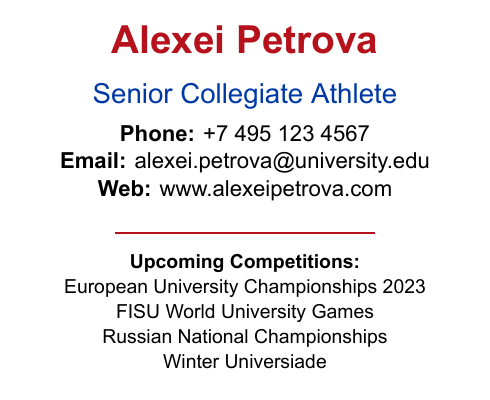what is the name on the business card? The name displayed prominently at the top of the document is Alexei Petrova.
Answer: Alexei Petrova what is the occupation listed on the card? The occupation is identified right below the name as Senior Collegiate Athlete.
Answer: Senior Collegiate Athlete what is the phone number provided? The phone number formatting reveals a contact number as +7 495 123 4567.
Answer: +7 495 123 4567 what upcoming competition is first on the list? The first listed upcoming competition is the European University Championships 2023.
Answer: European University Championships 2023 how many upcoming competitions are mentioned? The document mentions a total of four upcoming competitions.
Answer: 4 which color is used for the name? The color used for the name Alexei Petrova is identified as Russian Red.
Answer: Russian Red what is the web address provided? The web address listed on the card is www.alexeipetrova.com.
Answer: www.alexeipetrova.com what image type is included at the bottom of the card? The image included at the bottom is described as an example image.
Answer: example image where is the QR code located? The QR code is located in the lower left part of the card.
Answer: lower left part 